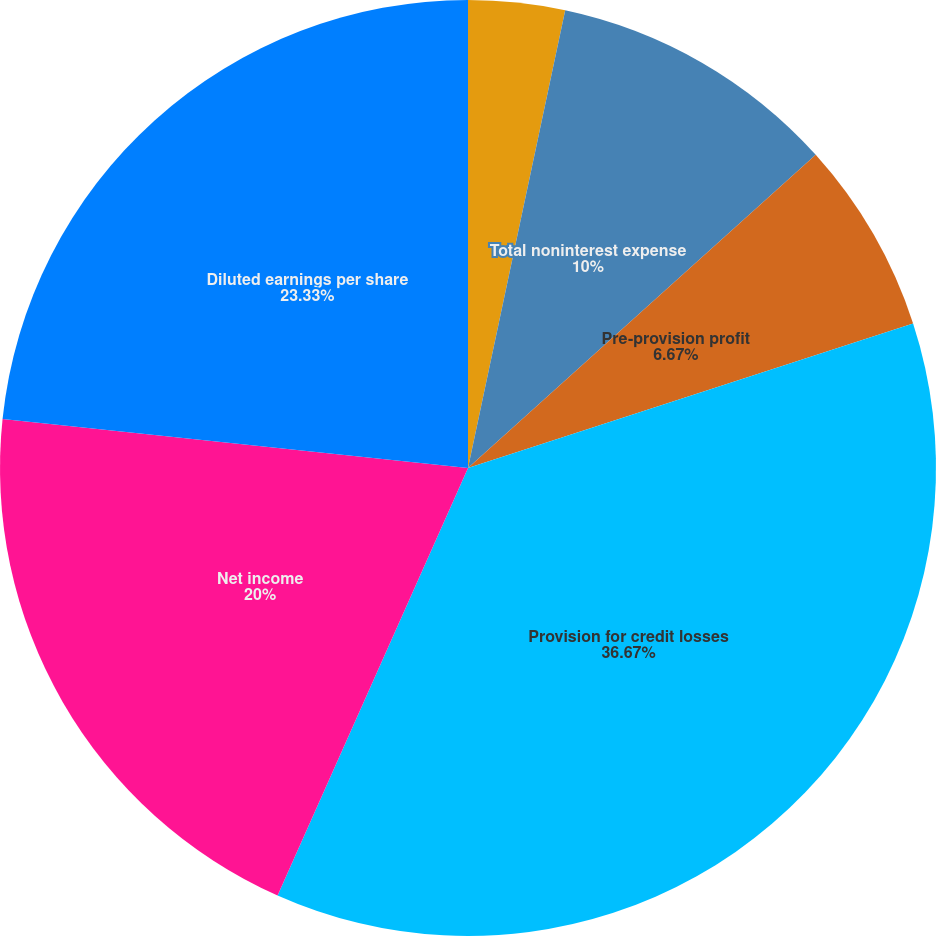Convert chart. <chart><loc_0><loc_0><loc_500><loc_500><pie_chart><fcel>Total net revenue<fcel>Total noninterest expense<fcel>Pre-provision profit<fcel>Provision for credit losses<fcel>Net income<fcel>Diluted earnings per share<nl><fcel>3.33%<fcel>10.0%<fcel>6.67%<fcel>36.67%<fcel>20.0%<fcel>23.33%<nl></chart> 